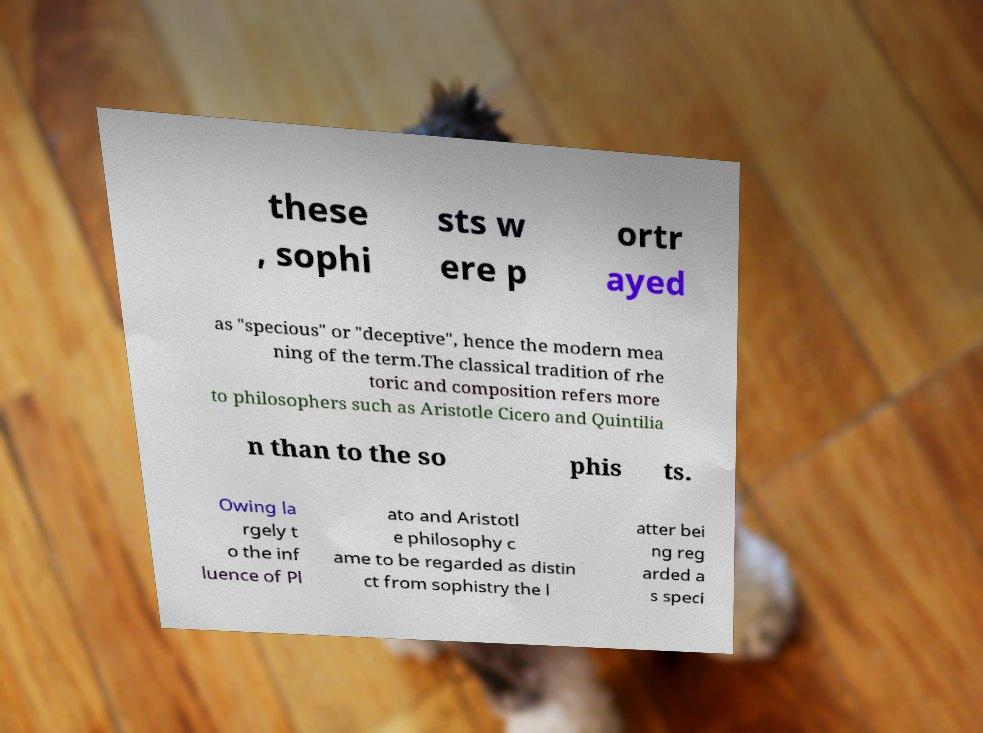For documentation purposes, I need the text within this image transcribed. Could you provide that? these , sophi sts w ere p ortr ayed as "specious" or "deceptive", hence the modern mea ning of the term.The classical tradition of rhe toric and composition refers more to philosophers such as Aristotle Cicero and Quintilia n than to the so phis ts. Owing la rgely t o the inf luence of Pl ato and Aristotl e philosophy c ame to be regarded as distin ct from sophistry the l atter bei ng reg arded a s speci 